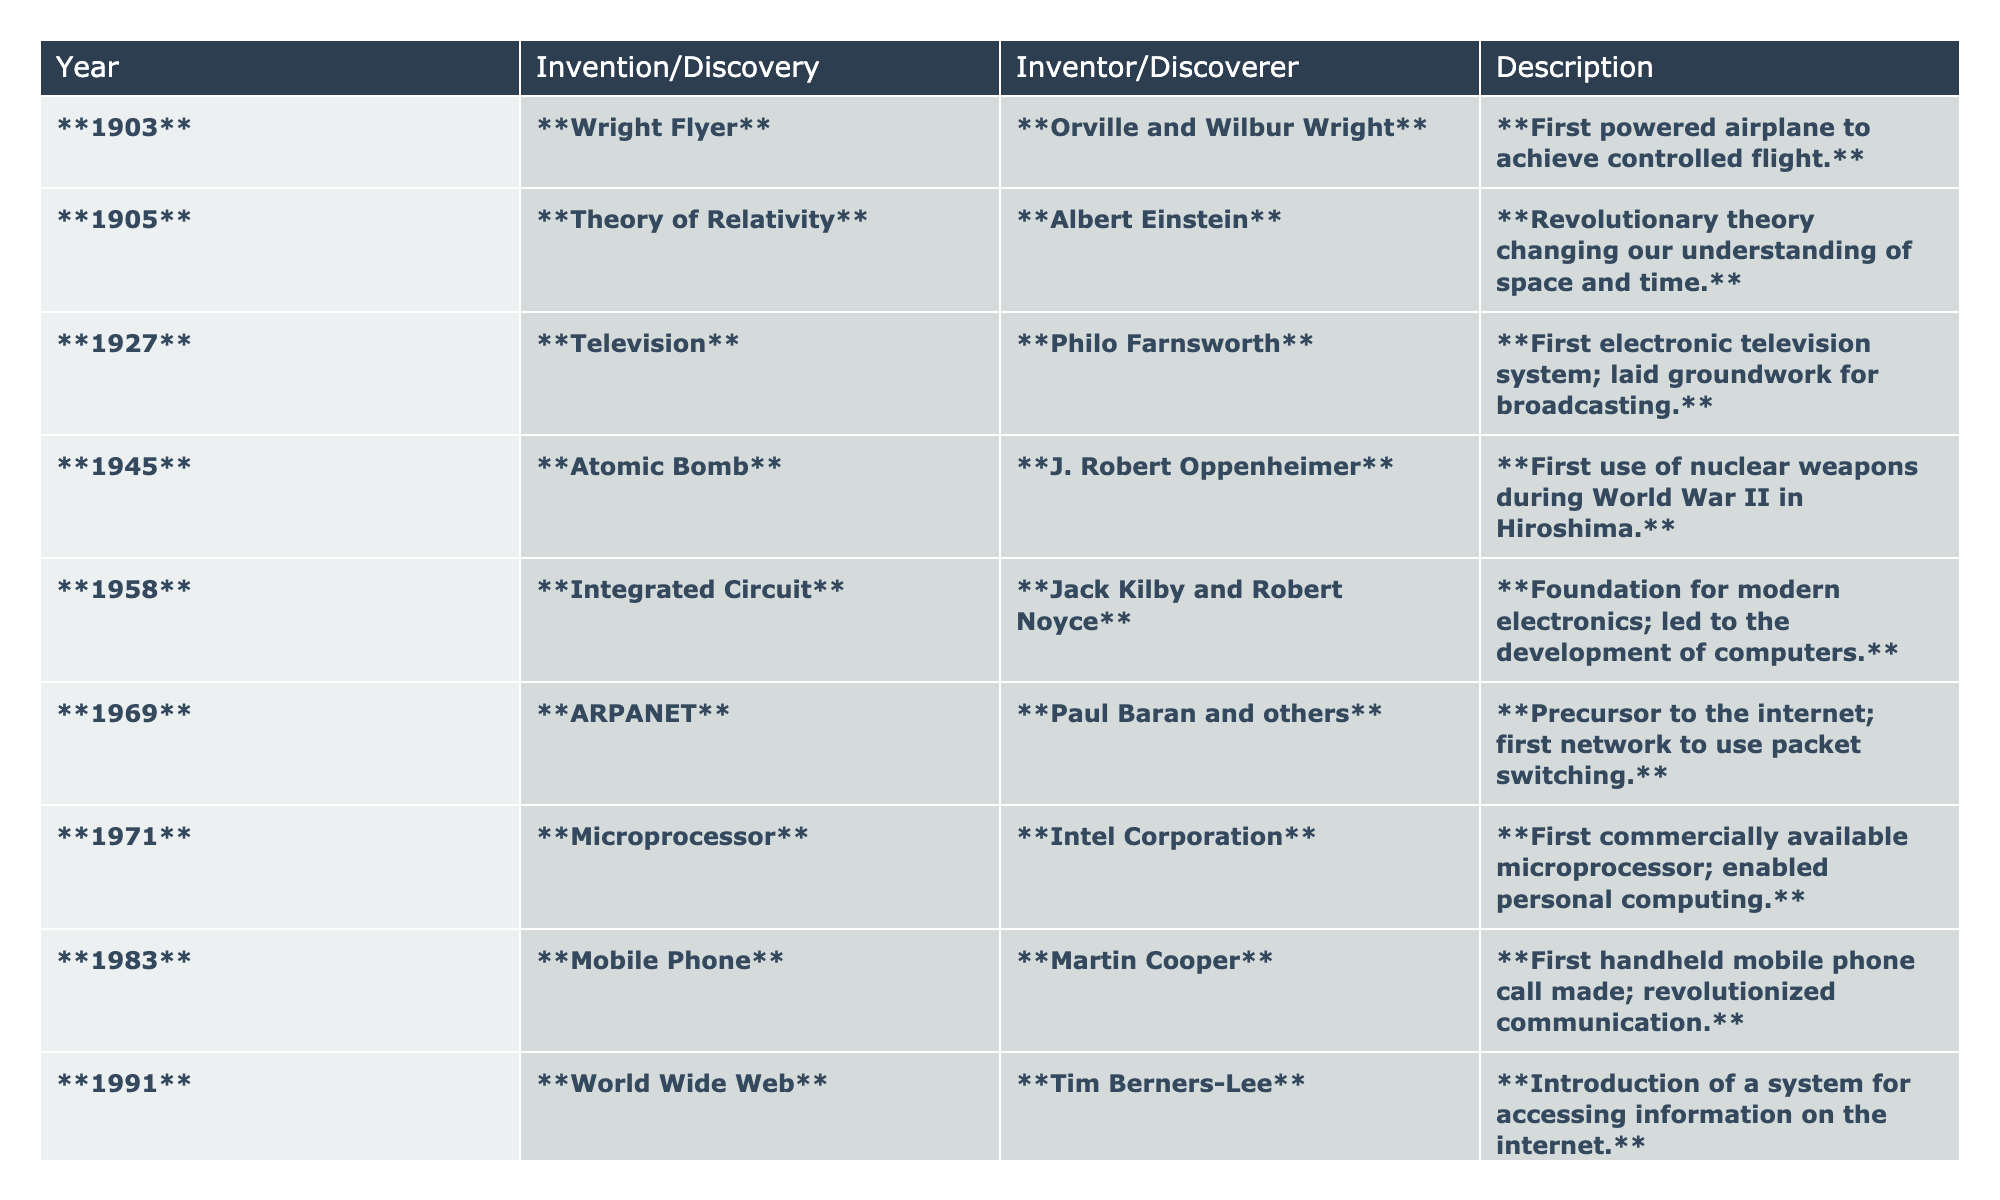What year was the first powered airplane invented? The table states that the Wright Flyer was invented in 1903, as indicated in the "Year" column.
Answer: 1903 Who invented the Theory of Relativity? According to the table, the Theory of Relativity was invented by Albert Einstein, as shown in the "Inventor/Discoverer" column.
Answer: Albert Einstein What was significant about the year 1945? The table indicates that in 1945, the Atomic Bomb was used during World War II; this is a major historical event marked in the "Invention/Discovery" column.
Answer: The use of the Atomic Bomb How many inventions or discoveries occurred before 1970? From the table, the inventions before 1970 are the Wright Flyer (1903), Theory of Relativity (1905), Television (1927), Atomic Bomb (1945), Integrated Circuit (1958), and ARPANET (1969) – totaling 6 inventions.
Answer: 6 What invention occurred in 1991 and who was its inventor? The table shows that in 1991, the World Wide Web was introduced by Tim Berners-Lee as stated in the "Invention/Discovery" and "Inventor/Discoverer" columns, respectively.
Answer: World Wide Web by Tim Berners-Lee Was the Integrated Circuit invented after the Atomic Bomb? The table lists the Integrated Circuit's invention in 1958 and the Atomic Bomb's use in 1945, confirming that the Integrated Circuit was indeed invented after the Atomic Bomb.
Answer: Yes Which invention in the table is the most recent and who discovered it? The table indicates the Human Genome Project Launch in 1997 as the most recent invention, discovered by Francis Collins and the Genome Consortium.
Answer: Human Genome Project Launch by Francis Collins What is the difference in years between the invention of the Microprocessor and the Wright Flyer? The Wright Flyer was invented in 1903 and the Microprocessor in 1971. Thus, the difference is 1971 - 1903 = 68 years.
Answer: 68 years How many inventors contributed to the invention of the first electronically operated television system? The table identifies Philo Farnsworth as the inventor of the Television system, suggesting only one inventor is credited for this invention.
Answer: 1 List all inventions that occurred during the 1980s according to the table. The table states that the only invention during the 1980s listed is the Mobile Phone in 1983, confirming it as the sole invention of that decade.
Answer: Mobile Phone in 1983 Which invention would you say had the greatest impact on personal computing? Considering the table, the Integrated Circuit is noted as the foundation for modern electronics and led to the development of computers, marking it as highly impactful for personal computing.
Answer: Integrated Circuit 